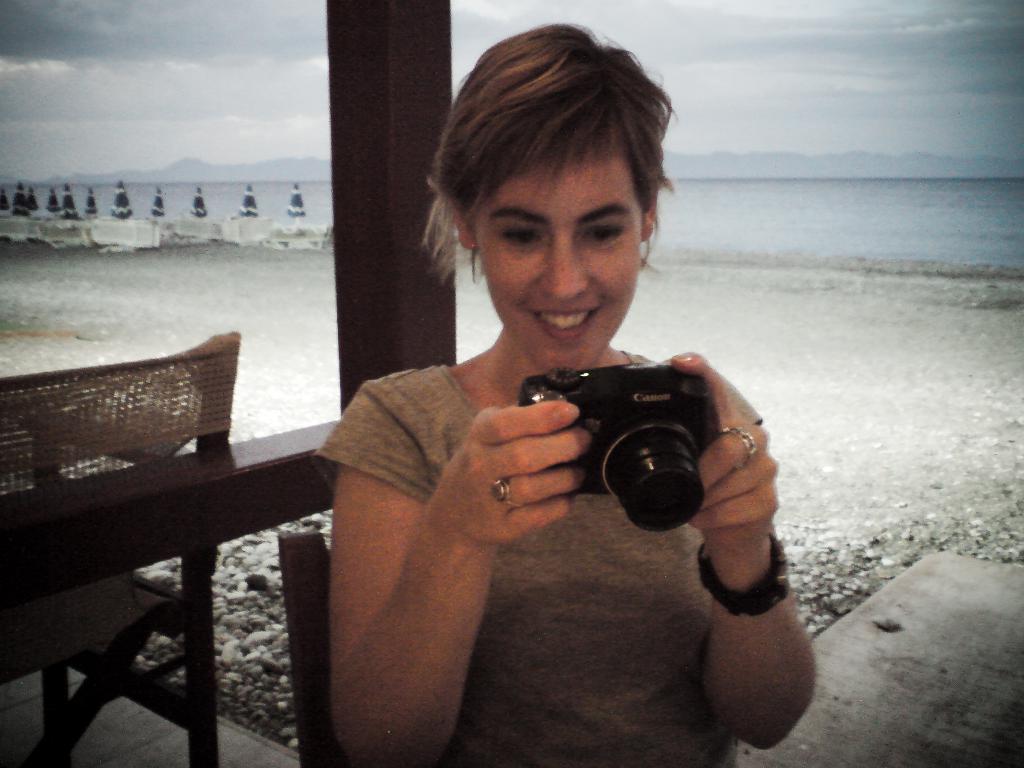In one or two sentences, can you explain what this image depicts? In this picture a lady is holding a canon camera and the scene is clicked near the sea. There is also a brown chair to the left of the image. 